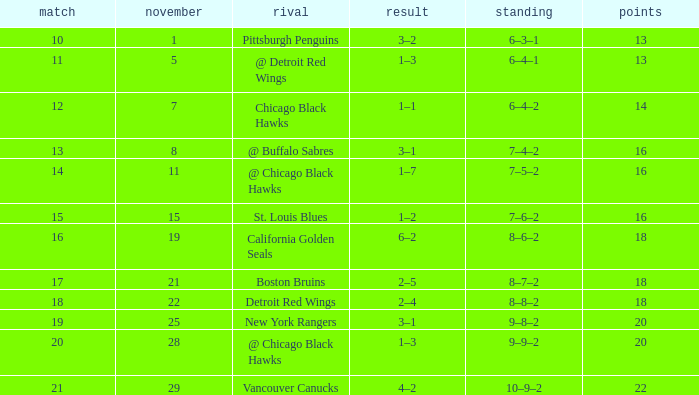What record has a november greater than 11, and st. louis blues as the opponent? 7–6–2. 